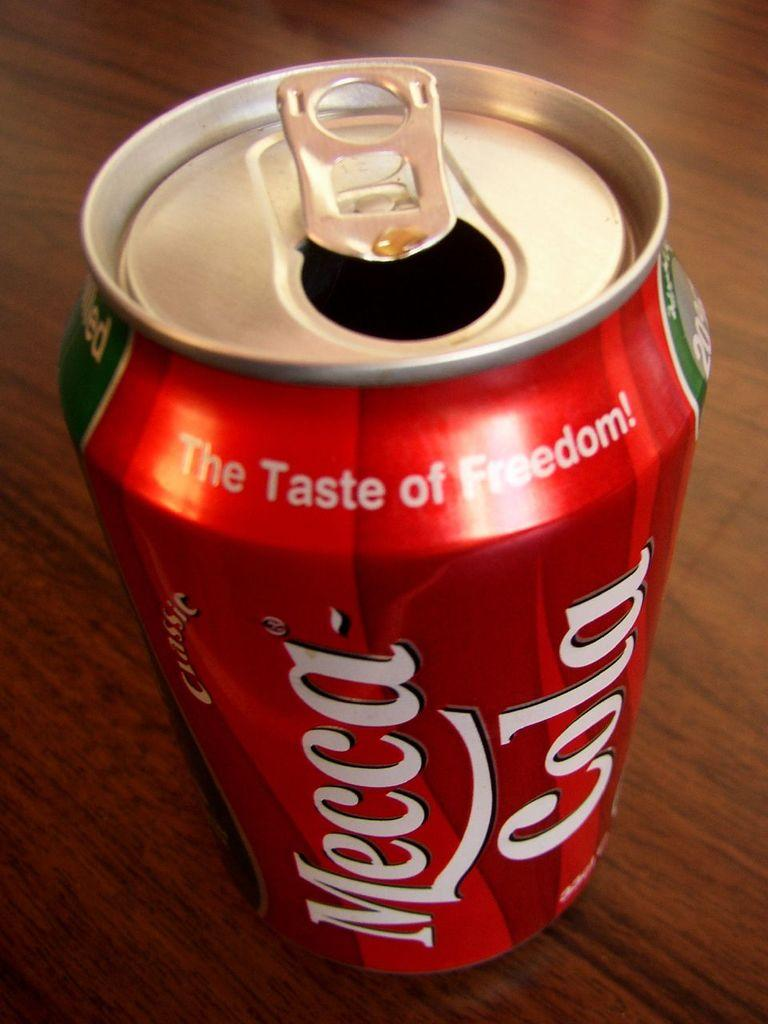Provide a one-sentence caption for the provided image. Mecca cola can that is red and sitting on a table. 